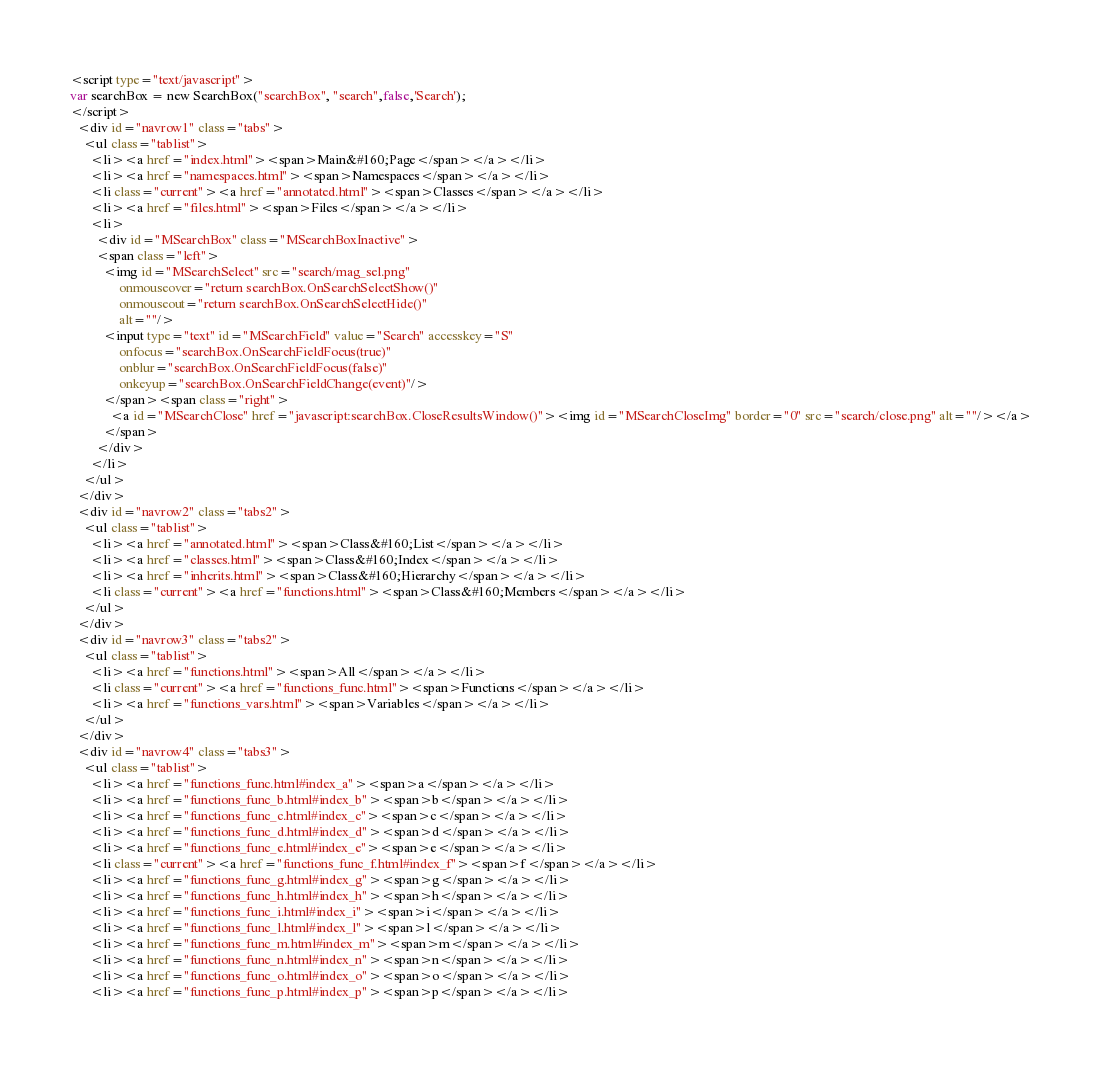<code> <loc_0><loc_0><loc_500><loc_500><_HTML_><script type="text/javascript">
var searchBox = new SearchBox("searchBox", "search",false,'Search');
</script>
  <div id="navrow1" class="tabs">
    <ul class="tablist">
      <li><a href="index.html"><span>Main&#160;Page</span></a></li>
      <li><a href="namespaces.html"><span>Namespaces</span></a></li>
      <li class="current"><a href="annotated.html"><span>Classes</span></a></li>
      <li><a href="files.html"><span>Files</span></a></li>
      <li>
        <div id="MSearchBox" class="MSearchBoxInactive">
        <span class="left">
          <img id="MSearchSelect" src="search/mag_sel.png"
               onmouseover="return searchBox.OnSearchSelectShow()"
               onmouseout="return searchBox.OnSearchSelectHide()"
               alt=""/>
          <input type="text" id="MSearchField" value="Search" accesskey="S"
               onfocus="searchBox.OnSearchFieldFocus(true)" 
               onblur="searchBox.OnSearchFieldFocus(false)" 
               onkeyup="searchBox.OnSearchFieldChange(event)"/>
          </span><span class="right">
            <a id="MSearchClose" href="javascript:searchBox.CloseResultsWindow()"><img id="MSearchCloseImg" border="0" src="search/close.png" alt=""/></a>
          </span>
        </div>
      </li>
    </ul>
  </div>
  <div id="navrow2" class="tabs2">
    <ul class="tablist">
      <li><a href="annotated.html"><span>Class&#160;List</span></a></li>
      <li><a href="classes.html"><span>Class&#160;Index</span></a></li>
      <li><a href="inherits.html"><span>Class&#160;Hierarchy</span></a></li>
      <li class="current"><a href="functions.html"><span>Class&#160;Members</span></a></li>
    </ul>
  </div>
  <div id="navrow3" class="tabs2">
    <ul class="tablist">
      <li><a href="functions.html"><span>All</span></a></li>
      <li class="current"><a href="functions_func.html"><span>Functions</span></a></li>
      <li><a href="functions_vars.html"><span>Variables</span></a></li>
    </ul>
  </div>
  <div id="navrow4" class="tabs3">
    <ul class="tablist">
      <li><a href="functions_func.html#index_a"><span>a</span></a></li>
      <li><a href="functions_func_b.html#index_b"><span>b</span></a></li>
      <li><a href="functions_func_c.html#index_c"><span>c</span></a></li>
      <li><a href="functions_func_d.html#index_d"><span>d</span></a></li>
      <li><a href="functions_func_e.html#index_e"><span>e</span></a></li>
      <li class="current"><a href="functions_func_f.html#index_f"><span>f</span></a></li>
      <li><a href="functions_func_g.html#index_g"><span>g</span></a></li>
      <li><a href="functions_func_h.html#index_h"><span>h</span></a></li>
      <li><a href="functions_func_i.html#index_i"><span>i</span></a></li>
      <li><a href="functions_func_l.html#index_l"><span>l</span></a></li>
      <li><a href="functions_func_m.html#index_m"><span>m</span></a></li>
      <li><a href="functions_func_n.html#index_n"><span>n</span></a></li>
      <li><a href="functions_func_o.html#index_o"><span>o</span></a></li>
      <li><a href="functions_func_p.html#index_p"><span>p</span></a></li></code> 